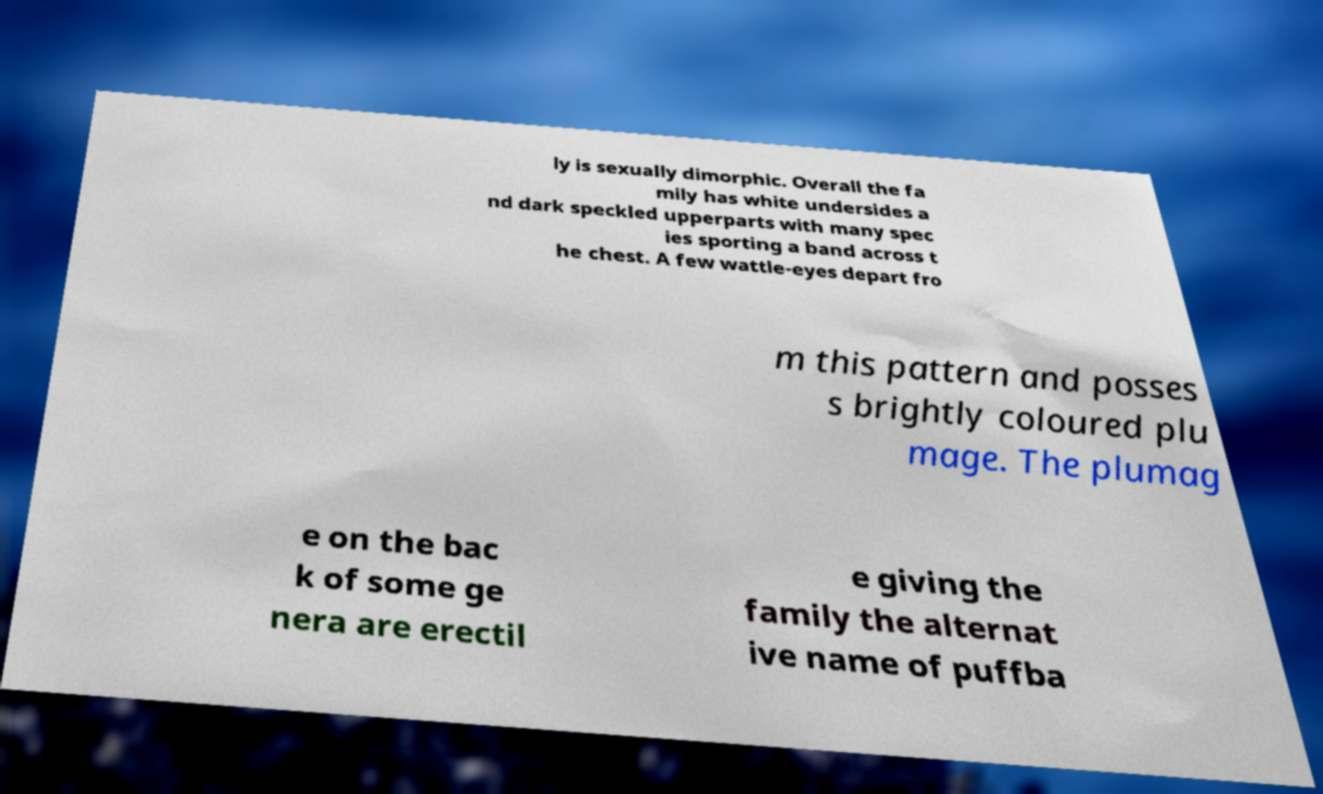Please identify and transcribe the text found in this image. ly is sexually dimorphic. Overall the fa mily has white undersides a nd dark speckled upperparts with many spec ies sporting a band across t he chest. A few wattle-eyes depart fro m this pattern and posses s brightly coloured plu mage. The plumag e on the bac k of some ge nera are erectil e giving the family the alternat ive name of puffba 